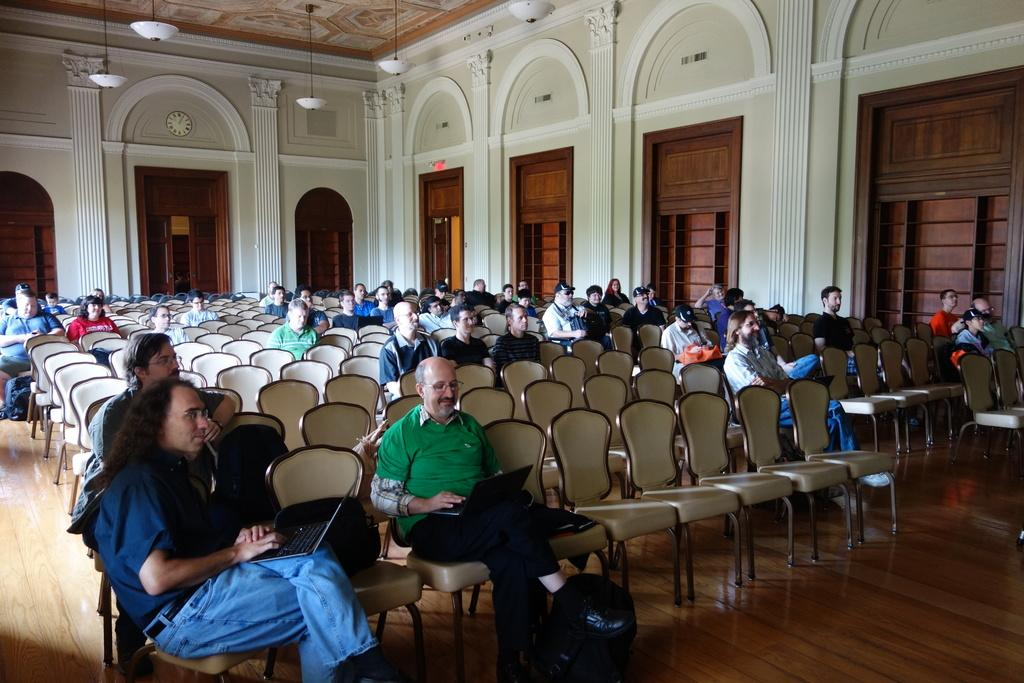What are the people in the image doing? The men and women in the image are sitting on chairs. What can be seen through the windows in the image? The facts do not provide information about what can be seen through the windows. What is the background of the image made of? There is a wall in the image, which is likely part of the background. What types of toys are the people playing with in the image? There are no toys present in the image; the people are sitting on chairs. What is the source of pleasure for the people in the image? The facts do not provide information about the people's emotions or sources of pleasure. 